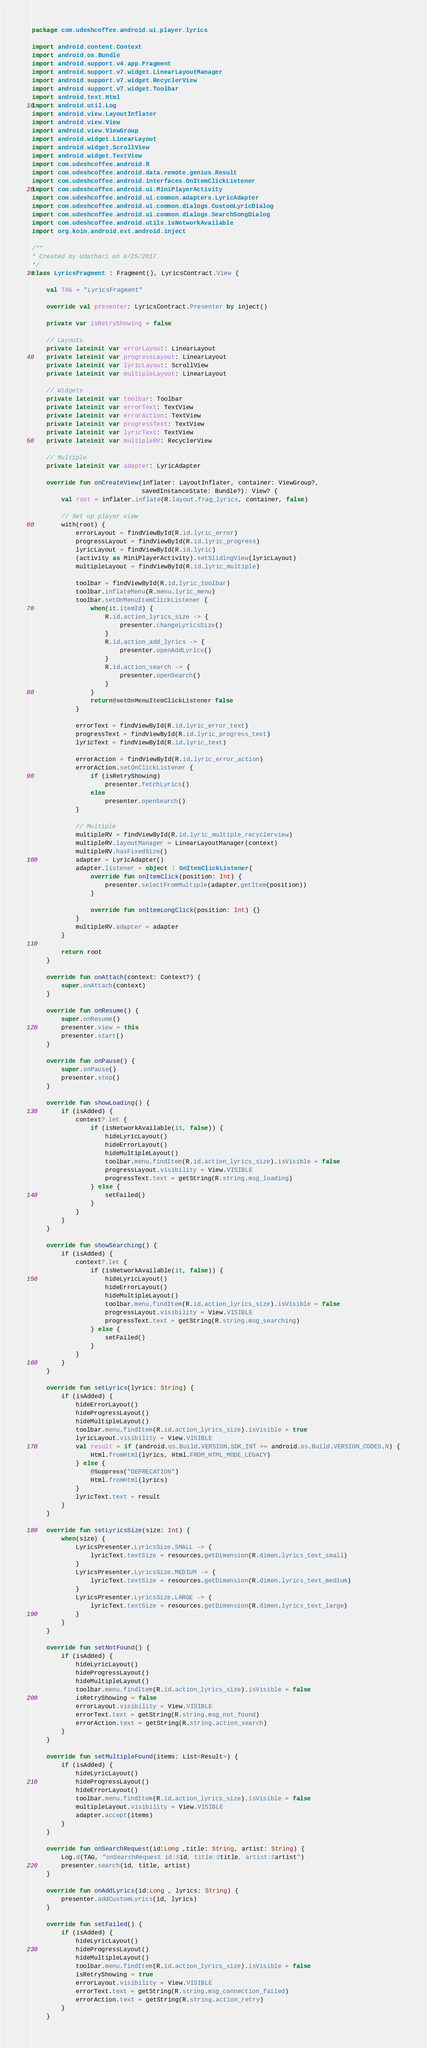Convert code to text. <code><loc_0><loc_0><loc_500><loc_500><_Kotlin_>package com.udeshcoffee.android.ui.player.lyrics

import android.content.Context
import android.os.Bundle
import android.support.v4.app.Fragment
import android.support.v7.widget.LinearLayoutManager
import android.support.v7.widget.RecyclerView
import android.support.v7.widget.Toolbar
import android.text.Html
import android.util.Log
import android.view.LayoutInflater
import android.view.View
import android.view.ViewGroup
import android.widget.LinearLayout
import android.widget.ScrollView
import android.widget.TextView
import com.udeshcoffee.android.R
import com.udeshcoffee.android.data.remote.genius.Result
import com.udeshcoffee.android.interfaces.OnItemClickListener
import com.udeshcoffee.android.ui.MiniPlayerActivity
import com.udeshcoffee.android.ui.common.adapters.LyricAdapter
import com.udeshcoffee.android.ui.common.dialogs.CustomLyricDialog
import com.udeshcoffee.android.ui.common.dialogs.SearchSongDialog
import com.udeshcoffee.android.utils.isNetworkAvailable
import org.koin.android.ext.android.inject

/**
* Created by Udathari on 8/25/2017.
*/
class LyricsFragment : Fragment(), LyricsContract.View {

    val TAG = "LyricsFragment"

    override val presenter: LyricsContract.Presenter by inject()

    private var isRetryShowing = false

    // Layouts
    private lateinit var errorLayout: LinearLayout
    private lateinit var progressLayout: LinearLayout
    private lateinit var lyricLayout: ScrollView
    private lateinit var multipleLayout: LinearLayout

    // Widgets
    private lateinit var toolbar: Toolbar
    private lateinit var errorText: TextView
    private lateinit var errorAction: TextView
    private lateinit var progressText: TextView
    private lateinit var lyricText: TextView
    private lateinit var multipleRV: RecyclerView

    // Multiple
    private lateinit var adapter: LyricAdapter

    override fun onCreateView(inflater: LayoutInflater, container: ViewGroup?,
                              savedInstanceState: Bundle?): View? {
        val root = inflater.inflate(R.layout.frag_lyrics, container, false)

        // Set up player view
        with(root) {
            errorLayout = findViewById(R.id.lyric_error)
            progressLayout = findViewById(R.id.lyric_progress)
            lyricLayout = findViewById(R.id.lyric)
            (activity as MiniPlayerActivity).setSlidingView(lyricLayout)
            multipleLayout = findViewById(R.id.lyric_multiple)

            toolbar = findViewById(R.id.lyric_toolbar)
            toolbar.inflateMenu(R.menu.lyric_menu)
            toolbar.setOnMenuItemClickListener {
                when(it.itemId) {
                    R.id.action_lyrics_size -> {
                        presenter.changeLyricsSize()
                    }
                    R.id.action_add_lyrics -> {
                        presenter.openAddLyrics()
                    }
                    R.id.action_search -> {
                        presenter.openSearch()
                    }
                }
                return@setOnMenuItemClickListener false
            }

            errorText = findViewById(R.id.lyric_error_text)
            progressText = findViewById(R.id.lyric_progress_text)
            lyricText = findViewById(R.id.lyric_text)

            errorAction = findViewById(R.id.lyric_error_action)
            errorAction.setOnClickListener {
                if (isRetryShowing)
                    presenter.fetchLyrics()
                else
                    presenter.openSearch()
            }

            // Multiple
            multipleRV = findViewById(R.id.lyric_multiple_recyclerview)
            multipleRV.layoutManager = LinearLayoutManager(context)
            multipleRV.hasFixedSize()
            adapter = LyricAdapter()
            adapter.listener = object : OnItemClickListener{
                override fun onItemClick(position: Int) {
                    presenter.selectFromMultiple(adapter.getItem(position))
                }

                override fun onItemLongClick(position: Int) {}
            }
            multipleRV.adapter = adapter
        }

        return root
    }

    override fun onAttach(context: Context?) {
        super.onAttach(context)
    }

    override fun onResume() {
        super.onResume()
        presenter.view = this
        presenter.start()
    }

    override fun onPause() {
        super.onPause()
        presenter.stop()
    }

    override fun showLoading() {
        if (isAdded) {
            context?.let {
                if (isNetworkAvailable(it, false)) {
                    hideLyricLayout()
                    hideErrorLayout()
                    hideMultipleLayout()
                    toolbar.menu.findItem(R.id.action_lyrics_size).isVisible = false
                    progressLayout.visibility = View.VISIBLE
                    progressText.text = getString(R.string.msg_loading)
                } else {
                    setFailed()
                }
            }
        }
    }

    override fun showSearching() {
        if (isAdded) {
            context?.let {
                if (isNetworkAvailable(it, false)) {
                    hideLyricLayout()
                    hideErrorLayout()
                    hideMultipleLayout()
                    toolbar.menu.findItem(R.id.action_lyrics_size).isVisible = false
                    progressLayout.visibility = View.VISIBLE
                    progressText.text = getString(R.string.msg_searching)
                } else {
                    setFailed()
                }
            }
        }
    }

    override fun setLyrics(lyrics: String) {
        if (isAdded) {
            hideErrorLayout()
            hideProgressLayout()
            hideMultipleLayout()
            toolbar.menu.findItem(R.id.action_lyrics_size).isVisible = true
            lyricLayout.visibility = View.VISIBLE
            val result = if (android.os.Build.VERSION.SDK_INT >= android.os.Build.VERSION_CODES.N) {
                Html.fromHtml(lyrics, Html.FROM_HTML_MODE_LEGACY)
            } else {
                @Suppress("DEPRECATION")
                Html.fromHtml(lyrics)
            }
            lyricText.text = result
        }
    }

    override fun setLyricsSize(size: Int) {
        when(size) {
            LyricsPresenter.LyricsSize.SMALL -> {
                lyricText.textSize = resources.getDimension(R.dimen.lyrics_text_small)
            }
            LyricsPresenter.LyricsSize.MEDIUM -> {
                lyricText.textSize = resources.getDimension(R.dimen.lyrics_text_medium)
            }
            LyricsPresenter.LyricsSize.LARGE -> {
                lyricText.textSize = resources.getDimension(R.dimen.lyrics_text_large)
            }
        }
    }

    override fun setNotFound() {
        if (isAdded) {
            hideLyricLayout()
            hideProgressLayout()
            hideMultipleLayout()
            toolbar.menu.findItem(R.id.action_lyrics_size).isVisible = false
            isRetryShowing = false
            errorLayout.visibility = View.VISIBLE
            errorText.text = getString(R.string.msg_not_found)
            errorAction.text = getString(R.string.action_search)
        }
    }

    override fun setMultipleFound(items: List<Result>) {
        if (isAdded) {
            hideLyricLayout()
            hideProgressLayout()
            hideErrorLayout()
            toolbar.menu.findItem(R.id.action_lyrics_size).isVisible = false
            multipleLayout.visibility = View.VISIBLE
            adapter.accept(items)
        }
    }

    override fun onSearchRequest(id:Long ,title: String, artist: String) {
        Log.d(TAG, "onSearchRequest id:$id, title:$title, artist:$artist")
        presenter.search(id, title, artist)
    }

    override fun onAddLyrics(id:Long , lyrics: String) {
        presenter.addCustomLyrics(id, lyrics)
    }

    override fun setFailed() {
        if (isAdded) {
            hideLyricLayout()
            hideProgressLayout()
            hideMultipleLayout()
            toolbar.menu.findItem(R.id.action_lyrics_size).isVisible = false
            isRetryShowing = true
            errorLayout.visibility = View.VISIBLE
            errorText.text = getString(R.string.msg_connection_failed)
            errorAction.text = getString(R.string.action_retry)
        }
    }
</code> 